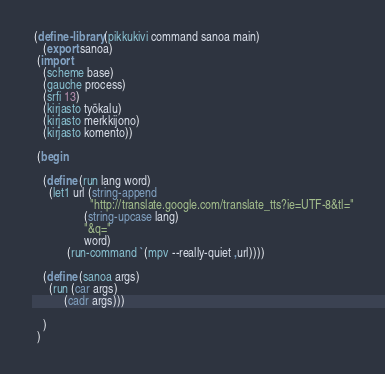Convert code to text. <code><loc_0><loc_0><loc_500><loc_500><_Scheme_>
 (define-library (pikkukivi command sanoa main)
    (export sanoa)
  (import
    (scheme base)
    (gauche process)
    (srfi 13)
    (kirjasto työkalu)
    (kirjasto merkkijono)
    (kirjasto komento))

  (begin

    (define (run lang word)
      (let1 url (string-append
                    "http://translate.google.com/translate_tts?ie=UTF-8&tl="
                  (string-upcase lang)
                  "&q="
                  word)
            (run-command `(mpv --really-quiet ,url))))

    (define (sanoa args)
      (run (car args)
           (cadr args)))

    )
  )
</code> 